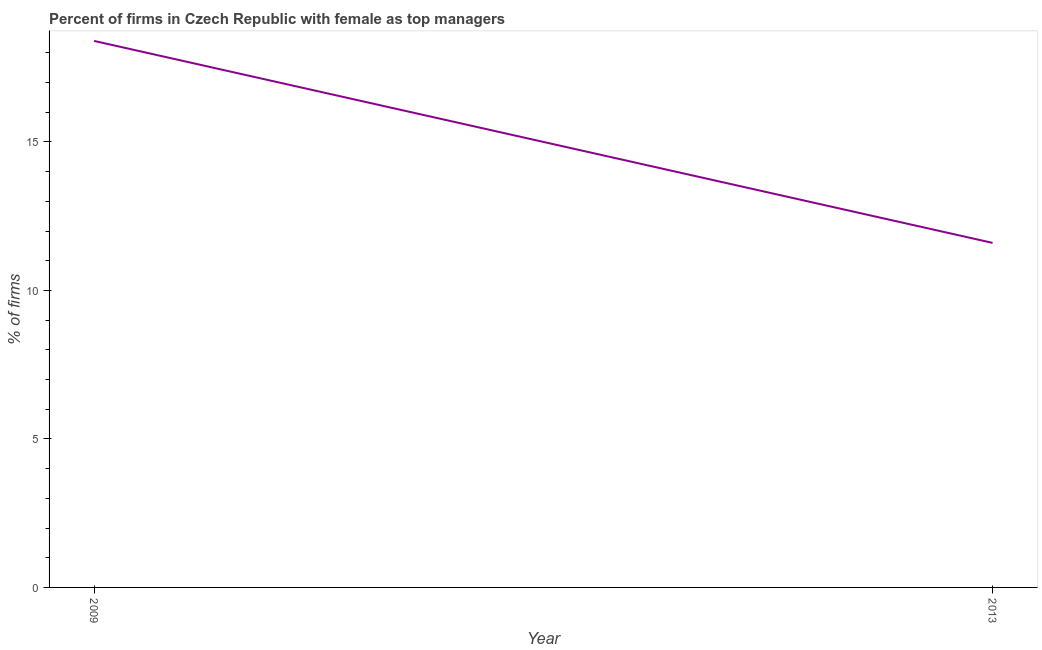What is the percentage of firms with female as top manager in 2009?
Ensure brevity in your answer.  18.4. Across all years, what is the minimum percentage of firms with female as top manager?
Make the answer very short. 11.6. What is the difference between the percentage of firms with female as top manager in 2009 and 2013?
Offer a terse response. 6.8. What is the median percentage of firms with female as top manager?
Your response must be concise. 15. Do a majority of the years between 2013 and 2009 (inclusive) have percentage of firms with female as top manager greater than 16 %?
Provide a succinct answer. No. What is the ratio of the percentage of firms with female as top manager in 2009 to that in 2013?
Offer a terse response. 1.59. Is the percentage of firms with female as top manager in 2009 less than that in 2013?
Keep it short and to the point. No. In how many years, is the percentage of firms with female as top manager greater than the average percentage of firms with female as top manager taken over all years?
Offer a very short reply. 1. How many lines are there?
Offer a very short reply. 1. Are the values on the major ticks of Y-axis written in scientific E-notation?
Provide a short and direct response. No. Does the graph contain grids?
Your answer should be compact. No. What is the title of the graph?
Your answer should be very brief. Percent of firms in Czech Republic with female as top managers. What is the label or title of the X-axis?
Make the answer very short. Year. What is the label or title of the Y-axis?
Give a very brief answer. % of firms. What is the % of firms of 2009?
Give a very brief answer. 18.4. What is the % of firms in 2013?
Give a very brief answer. 11.6. What is the ratio of the % of firms in 2009 to that in 2013?
Ensure brevity in your answer.  1.59. 